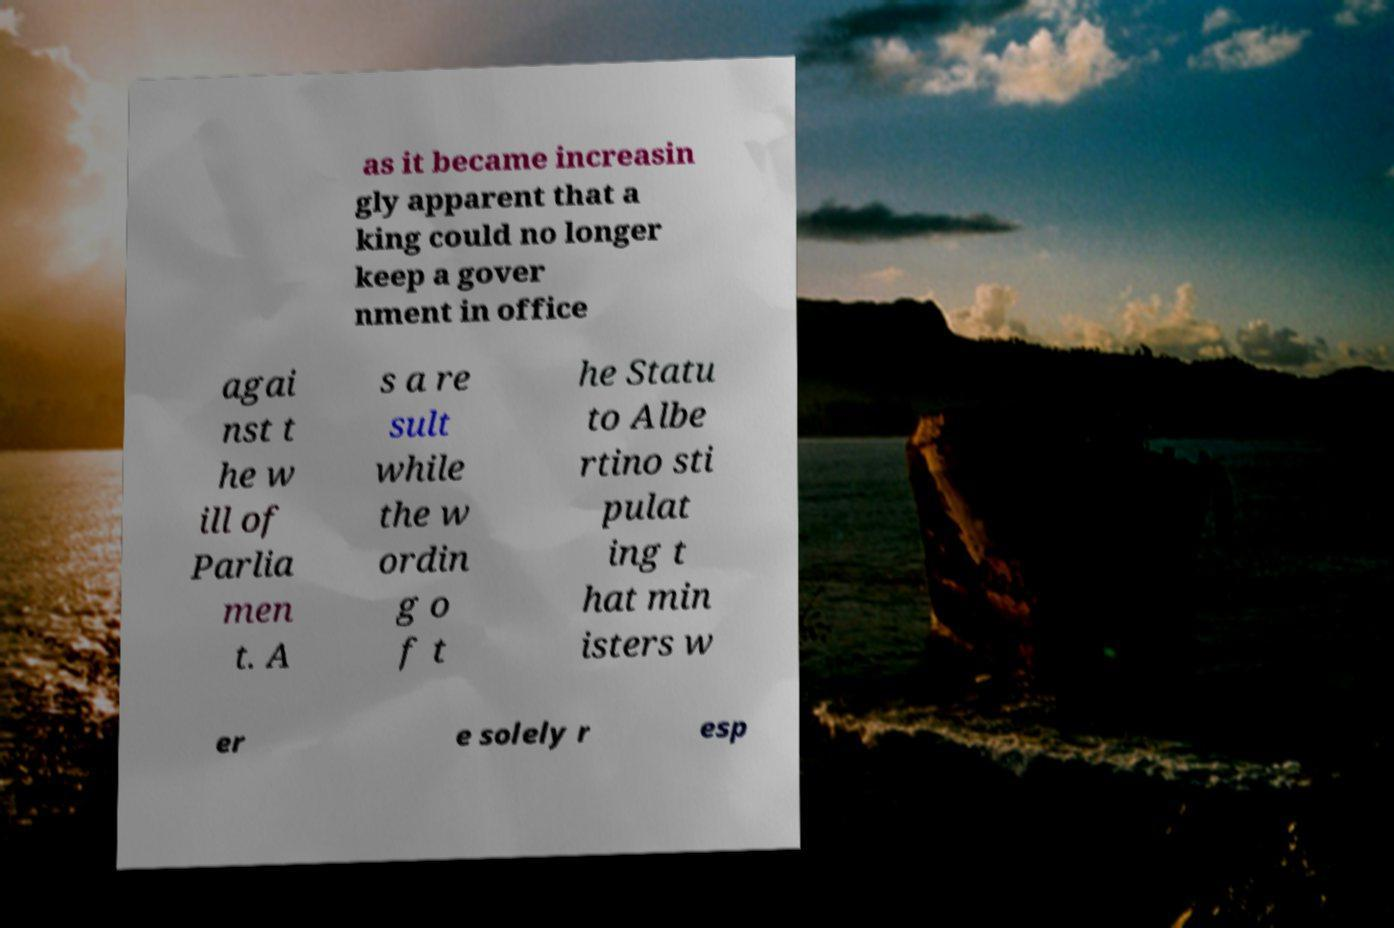Can you read and provide the text displayed in the image?This photo seems to have some interesting text. Can you extract and type it out for me? as it became increasin gly apparent that a king could no longer keep a gover nment in office agai nst t he w ill of Parlia men t. A s a re sult while the w ordin g o f t he Statu to Albe rtino sti pulat ing t hat min isters w er e solely r esp 